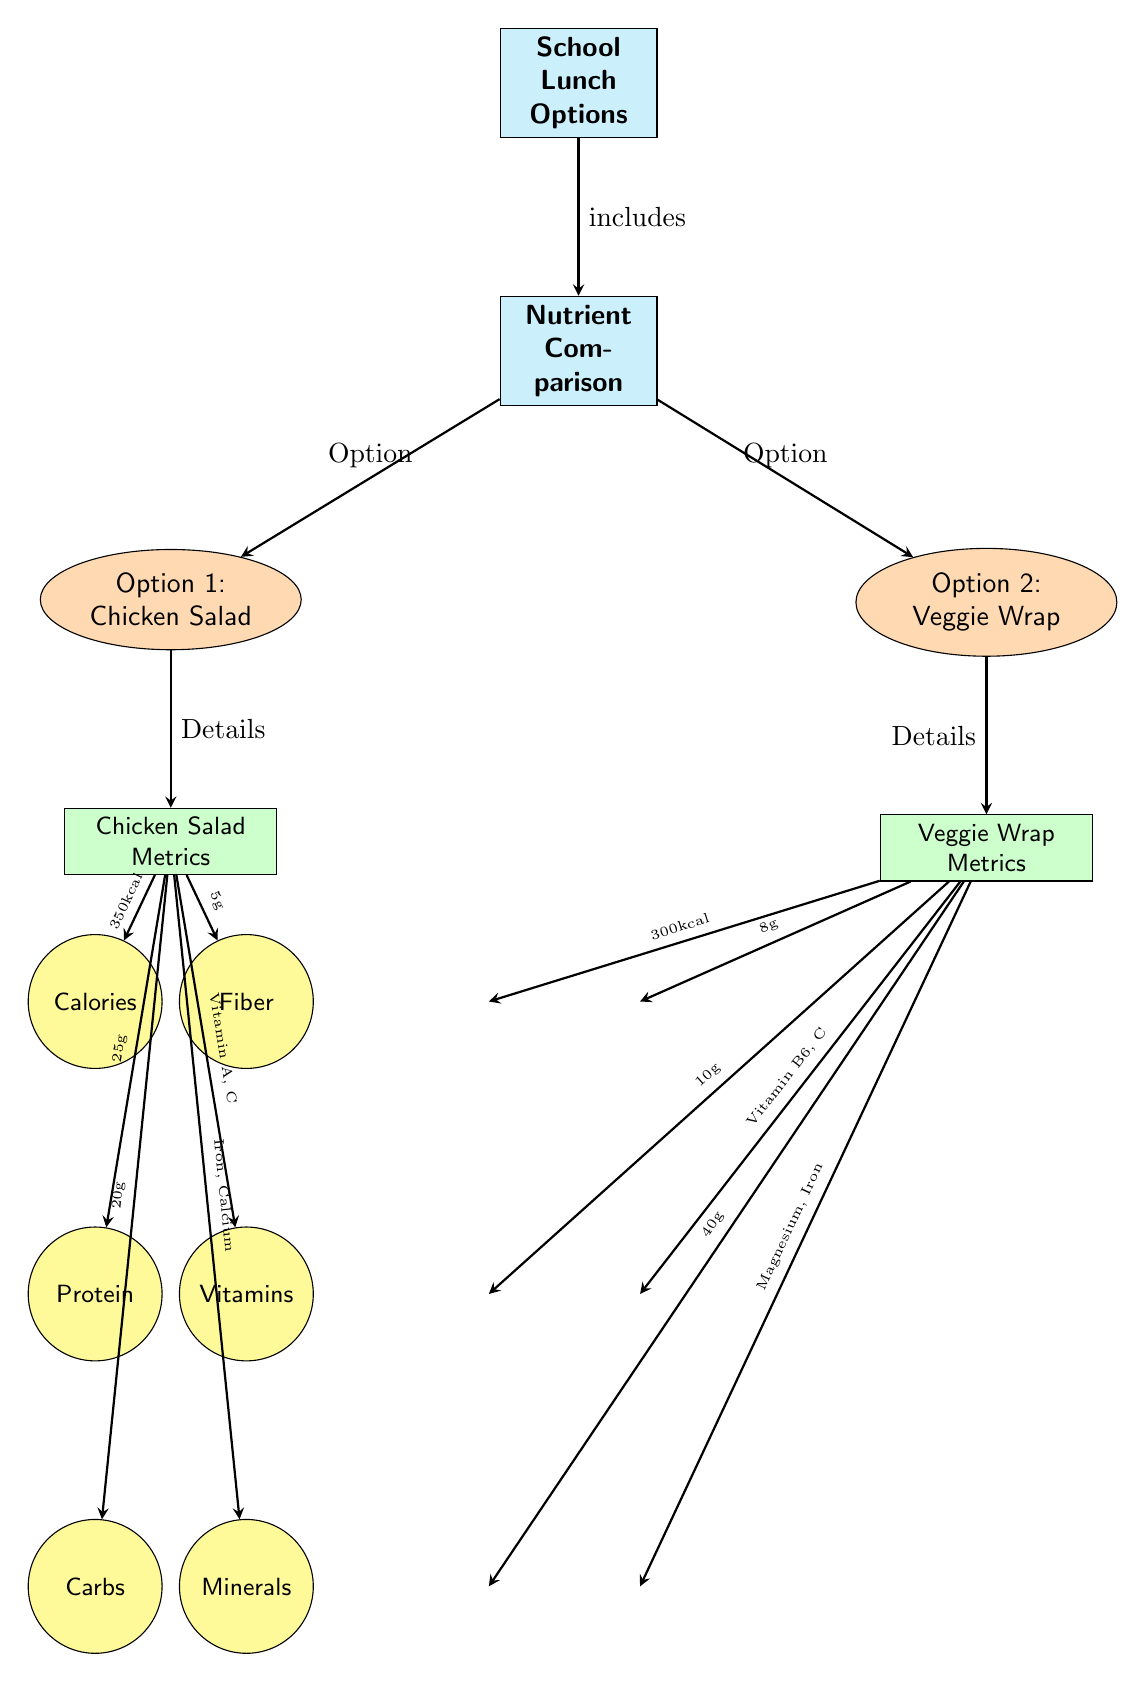What are the two school lunch options compared in the diagram? The diagram lists two lunch options: Chicken Salad and Veggie Wrap. This information is found in the nodes that branch from the "Nutrient Comparison" node, labeled as "Option 1" and "Option 2."
Answer: Chicken Salad, Veggie Wrap How many nutrients are listed for the Chicken Salad? The Chicken Salad metrics node lists six nutrients: Calories, Protein, Carbs, Fiber, Vitamins, and Minerals. Counting these nutrients gives the total of six.
Answer: 6 What is the calorie count for the Veggie Wrap? The Veggie Wrap metrics section indicates the calorie count as 300 kcal, as noted in the arrow leading from the Veggie Wrap Metrics node.
Answer: 300 kcal Which option has more protein? The Chicken Salad has 25g of protein, while the Veggie Wrap contains only 10g. Comparing these values indicates that Chicken Salad has more protein.
Answer: Chicken Salad What nutrients are present in the Chicken Salad? Referring to the nutrient nodes connected to the Chicken Salad Metrics node, we see it includes: Calories, Protein, Carbs, Fiber, Vitamins, and Minerals. These are all listed in distinct nodes below the chicken metrics.
Answer: Calories, Protein, Carbs, Fiber, Vitamins, Minerals What is the fiber content of the Veggie Wrap? The diagram displays the Veggie Wrap metrics, showing its fiber content as 8g, which is written clearly on the arrow connecting the Veggie Wrap Metrics to the Fiber nutrient node.
Answer: 8g Which option offers more vitamins? For the Chicken Salad, the vitamins include Vitamin A and C, while the Veggie Wrap contains Vitamin B6 and C. While both have Vitamin C, combining Vitamin A with it makes Chicken Salad the option with more variety in vitamins.
Answer: Chicken Salad What is the carb content of the Chicken Salad? The diagram indicates that the Chicken Salad contains 20g of carbs. This value is noted in the metric details directly stemming from the Chicken Salad Metrics node.
Answer: 20g Which option has more fiber? The Chicken Salad contains 5g of fiber, while the Veggie Wrap contains 8g. Therefore, by comparing these values, we can determine that the Veggie Wrap has more fiber than the Chicken Salad.
Answer: Veggie Wrap 